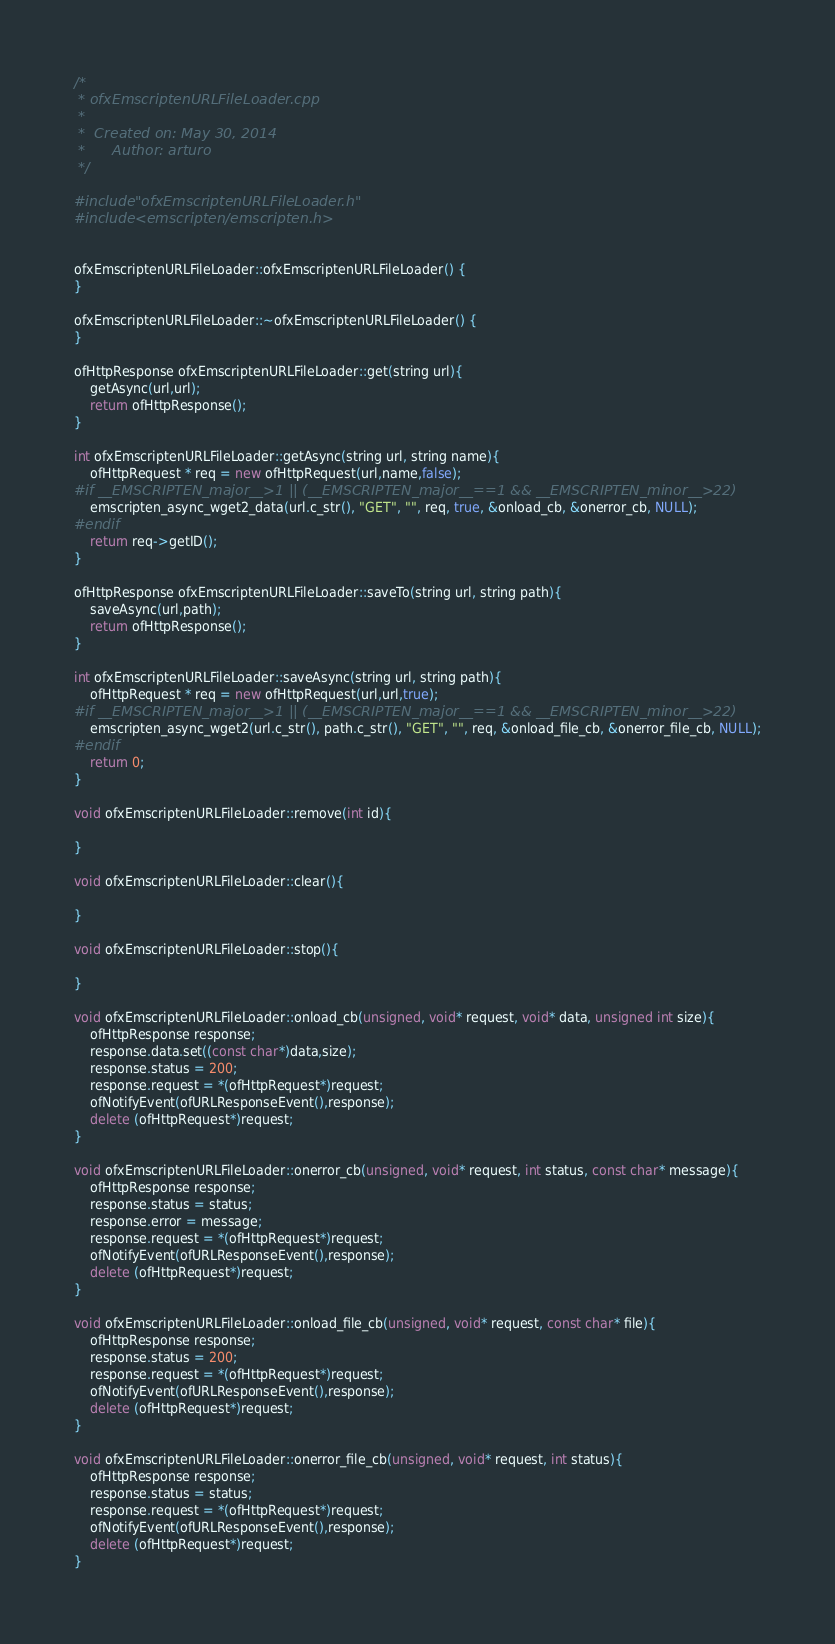<code> <loc_0><loc_0><loc_500><loc_500><_C++_>/*
 * ofxEmscriptenURLFileLoader.cpp
 *
 *  Created on: May 30, 2014
 *      Author: arturo
 */

#include "ofxEmscriptenURLFileLoader.h"
#include <emscripten/emscripten.h>


ofxEmscriptenURLFileLoader::ofxEmscriptenURLFileLoader() {
}

ofxEmscriptenURLFileLoader::~ofxEmscriptenURLFileLoader() {
}

ofHttpResponse ofxEmscriptenURLFileLoader::get(string url){
	getAsync(url,url);
	return ofHttpResponse();
}

int ofxEmscriptenURLFileLoader::getAsync(string url, string name){
	ofHttpRequest * req = new ofHttpRequest(url,name,false);
#if __EMSCRIPTEN_major__>1 || (__EMSCRIPTEN_major__==1 && __EMSCRIPTEN_minor__>22)
	emscripten_async_wget2_data(url.c_str(), "GET", "", req, true, &onload_cb, &onerror_cb, NULL);
#endif
	return req->getID();
}

ofHttpResponse ofxEmscriptenURLFileLoader::saveTo(string url, string path){
	saveAsync(url,path);
	return ofHttpResponse();
}

int ofxEmscriptenURLFileLoader::saveAsync(string url, string path){
	ofHttpRequest * req = new ofHttpRequest(url,url,true);
#if __EMSCRIPTEN_major__>1 || (__EMSCRIPTEN_major__==1 && __EMSCRIPTEN_minor__>22)
	emscripten_async_wget2(url.c_str(), path.c_str(), "GET", "", req, &onload_file_cb, &onerror_file_cb, NULL);
#endif
	return 0;
}

void ofxEmscriptenURLFileLoader::remove(int id){

}

void ofxEmscriptenURLFileLoader::clear(){

}

void ofxEmscriptenURLFileLoader::stop(){

}

void ofxEmscriptenURLFileLoader::onload_cb(unsigned, void* request, void* data, unsigned int size){
	ofHttpResponse response;
	response.data.set((const char*)data,size);
	response.status = 200;
	response.request = *(ofHttpRequest*)request;
	ofNotifyEvent(ofURLResponseEvent(),response);
	delete (ofHttpRequest*)request;
}

void ofxEmscriptenURLFileLoader::onerror_cb(unsigned, void* request, int status, const char* message){
	ofHttpResponse response;
	response.status = status;
	response.error = message;
	response.request = *(ofHttpRequest*)request;
	ofNotifyEvent(ofURLResponseEvent(),response);
	delete (ofHttpRequest*)request;
}

void ofxEmscriptenURLFileLoader::onload_file_cb(unsigned, void* request, const char* file){
	ofHttpResponse response;
	response.status = 200;
	response.request = *(ofHttpRequest*)request;
	ofNotifyEvent(ofURLResponseEvent(),response);
	delete (ofHttpRequest*)request;
}

void ofxEmscriptenURLFileLoader::onerror_file_cb(unsigned, void* request, int status){
	ofHttpResponse response;
	response.status = status;
	response.request = *(ofHttpRequest*)request;
	ofNotifyEvent(ofURLResponseEvent(),response);
	delete (ofHttpRequest*)request;
}
</code> 